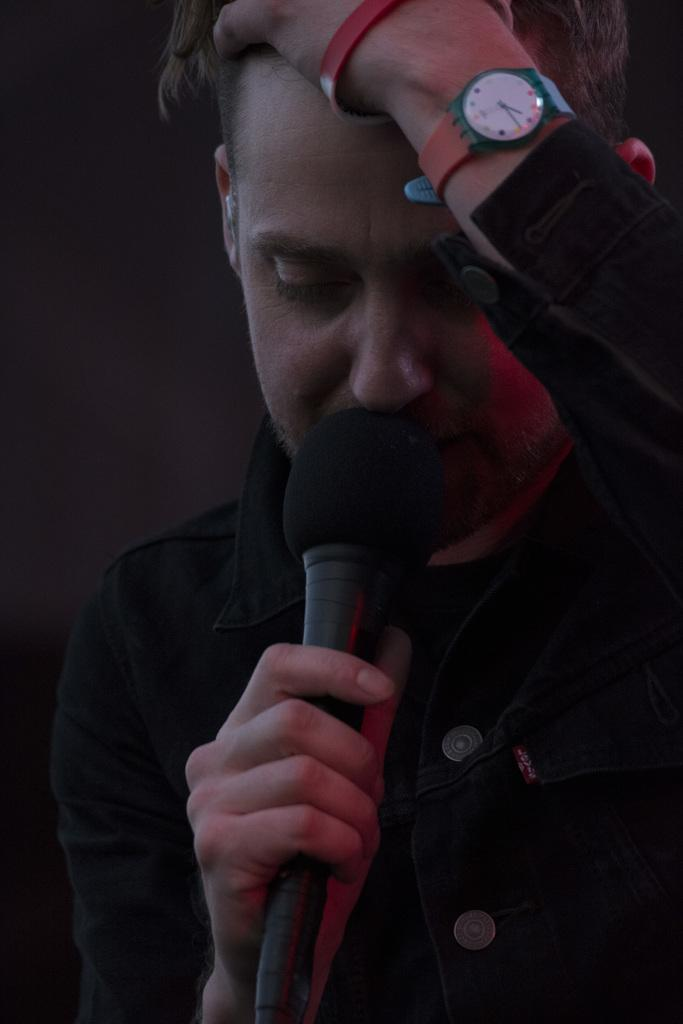Who is the main subject in the image? There is a man in the image. What is the man holding in the image? The man is holding a microphone. What accessory is the man wearing in the image? The man is wearing a watch on his hand. What is the size of the man's interest in the night sky in the image? There is no indication of the man's interest in the night sky in the image, as the focus is on the man holding a microphone and wearing a watch. 